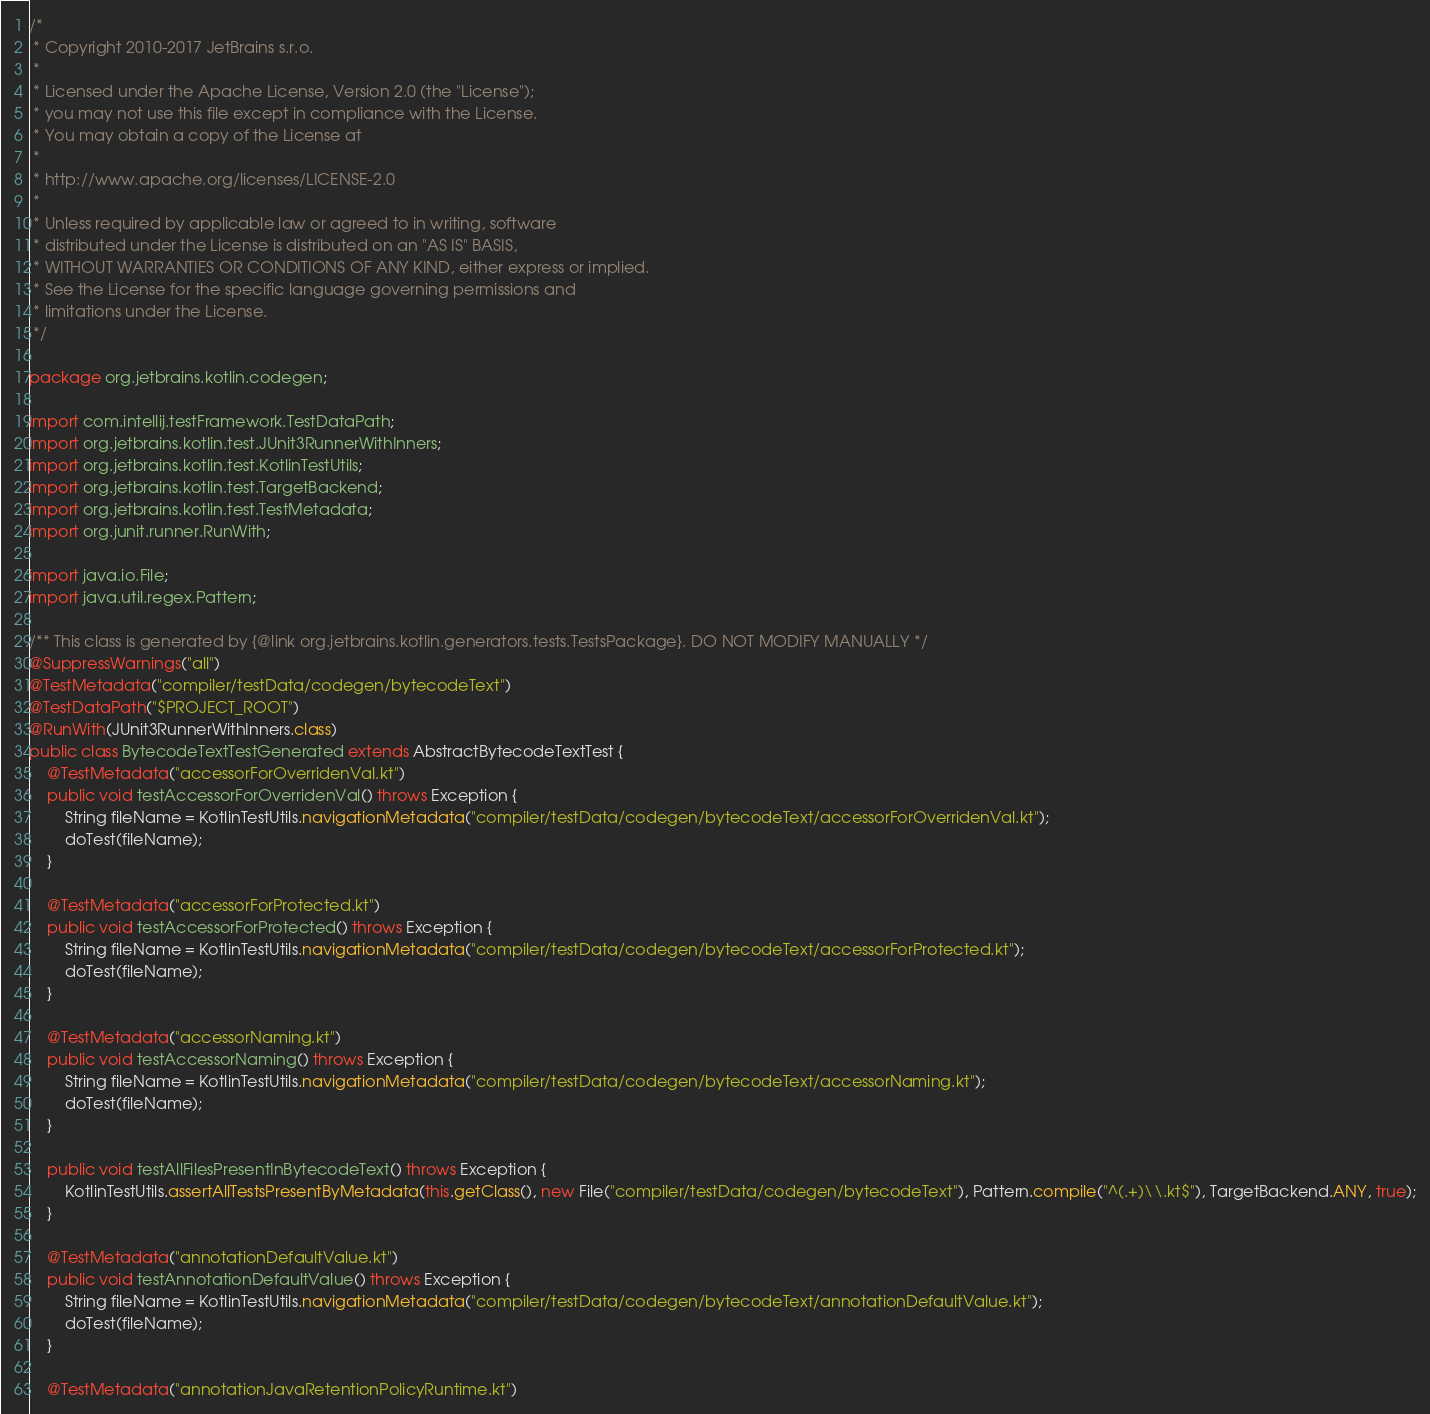Convert code to text. <code><loc_0><loc_0><loc_500><loc_500><_Java_>/*
 * Copyright 2010-2017 JetBrains s.r.o.
 *
 * Licensed under the Apache License, Version 2.0 (the "License");
 * you may not use this file except in compliance with the License.
 * You may obtain a copy of the License at
 *
 * http://www.apache.org/licenses/LICENSE-2.0
 *
 * Unless required by applicable law or agreed to in writing, software
 * distributed under the License is distributed on an "AS IS" BASIS,
 * WITHOUT WARRANTIES OR CONDITIONS OF ANY KIND, either express or implied.
 * See the License for the specific language governing permissions and
 * limitations under the License.
 */

package org.jetbrains.kotlin.codegen;

import com.intellij.testFramework.TestDataPath;
import org.jetbrains.kotlin.test.JUnit3RunnerWithInners;
import org.jetbrains.kotlin.test.KotlinTestUtils;
import org.jetbrains.kotlin.test.TargetBackend;
import org.jetbrains.kotlin.test.TestMetadata;
import org.junit.runner.RunWith;

import java.io.File;
import java.util.regex.Pattern;

/** This class is generated by {@link org.jetbrains.kotlin.generators.tests.TestsPackage}. DO NOT MODIFY MANUALLY */
@SuppressWarnings("all")
@TestMetadata("compiler/testData/codegen/bytecodeText")
@TestDataPath("$PROJECT_ROOT")
@RunWith(JUnit3RunnerWithInners.class)
public class BytecodeTextTestGenerated extends AbstractBytecodeTextTest {
    @TestMetadata("accessorForOverridenVal.kt")
    public void testAccessorForOverridenVal() throws Exception {
        String fileName = KotlinTestUtils.navigationMetadata("compiler/testData/codegen/bytecodeText/accessorForOverridenVal.kt");
        doTest(fileName);
    }

    @TestMetadata("accessorForProtected.kt")
    public void testAccessorForProtected() throws Exception {
        String fileName = KotlinTestUtils.navigationMetadata("compiler/testData/codegen/bytecodeText/accessorForProtected.kt");
        doTest(fileName);
    }

    @TestMetadata("accessorNaming.kt")
    public void testAccessorNaming() throws Exception {
        String fileName = KotlinTestUtils.navigationMetadata("compiler/testData/codegen/bytecodeText/accessorNaming.kt");
        doTest(fileName);
    }

    public void testAllFilesPresentInBytecodeText() throws Exception {
        KotlinTestUtils.assertAllTestsPresentByMetadata(this.getClass(), new File("compiler/testData/codegen/bytecodeText"), Pattern.compile("^(.+)\\.kt$"), TargetBackend.ANY, true);
    }

    @TestMetadata("annotationDefaultValue.kt")
    public void testAnnotationDefaultValue() throws Exception {
        String fileName = KotlinTestUtils.navigationMetadata("compiler/testData/codegen/bytecodeText/annotationDefaultValue.kt");
        doTest(fileName);
    }

    @TestMetadata("annotationJavaRetentionPolicyRuntime.kt")</code> 